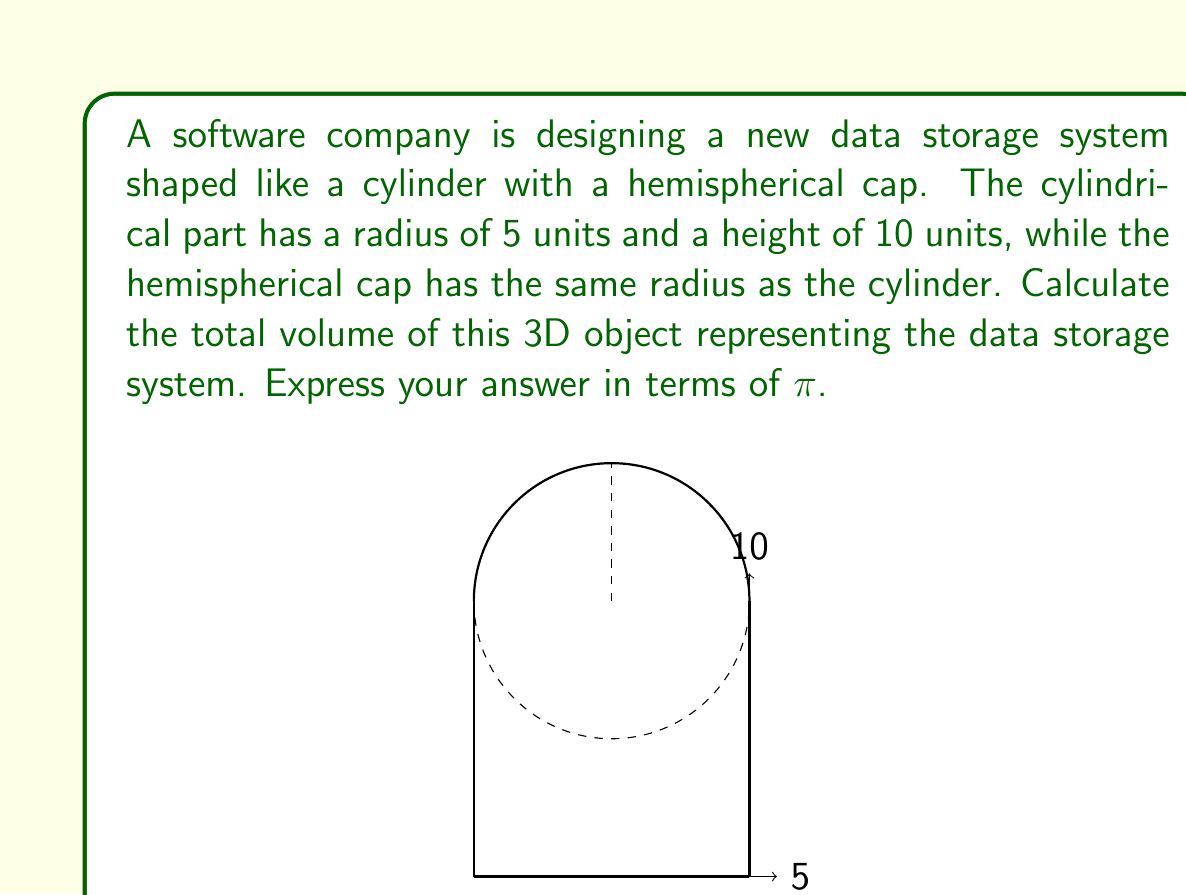What is the answer to this math problem? To solve this problem, we need to calculate the volume of two parts: the cylindrical section and the hemispherical cap. Then, we'll add these volumes together.

1. Volume of the cylindrical part:
   The formula for the volume of a cylinder is $V_{cylinder} = \pi r^2 h$
   where $r$ is the radius and $h$ is the height.
   
   $$V_{cylinder} = \pi (5^2) (10) = 250\pi$$

2. Volume of the hemispherical cap:
   The formula for the volume of a sphere is $V_{sphere} = \frac{4}{3}\pi r^3$
   Since we only have half a sphere, we'll divide this by 2.
   
   $$V_{hemisphere} = \frac{1}{2} \cdot \frac{4}{3}\pi r^3 = \frac{2}{3}\pi r^3$$
   $$V_{hemisphere} = \frac{2}{3}\pi (5^3) = \frac{250}{3}\pi$$

3. Total volume:
   We add the volumes of the cylinder and hemisphere:
   
   $$V_{total} = V_{cylinder} + V_{hemisphere}$$
   $$V_{total} = 250\pi + \frac{250}{3}\pi = \frac{750}{3}\pi + \frac{250}{3}\pi = \frac{1000}{3}\pi$$

Therefore, the total volume of the data storage system is $\frac{1000}{3}\pi$ cubic units.

This problem relates to your work as a junior software developer by demonstrating how mathematical concepts can be applied to model and calculate properties of physical storage systems. Understanding these concepts can be useful when working with data storage and optimization in software development.
Answer: $\frac{1000}{3}\pi$ cubic units 